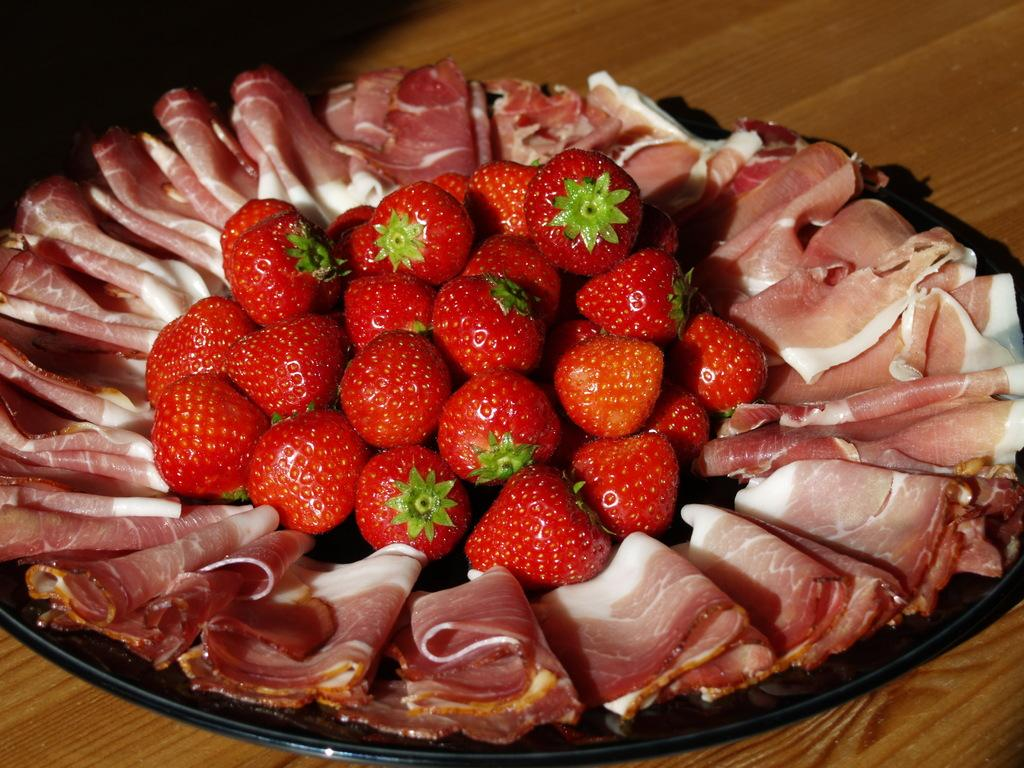What type of fruit is on the plate in the image? There are strawberries on the plate. What else is on the plate besides the strawberries? There is meat on the plate. What type of necklace is visible in the image? There is no necklace present in the image; it only features strawberries and meat on a plate. Is there a cave in the background of the image? There is no cave present in the image; it only features a plate with strawberries and meat. 